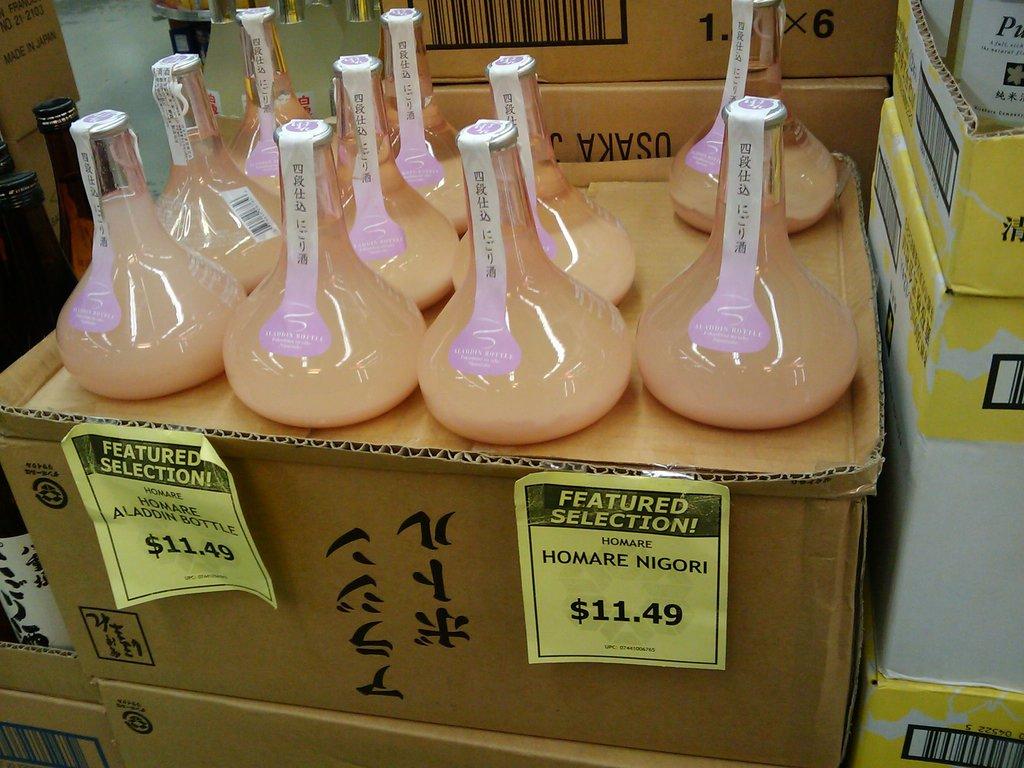How much does each product cost?
Provide a short and direct response. 11.49. What is the name of the product on the sign?
Your answer should be very brief. Homare nigori. 